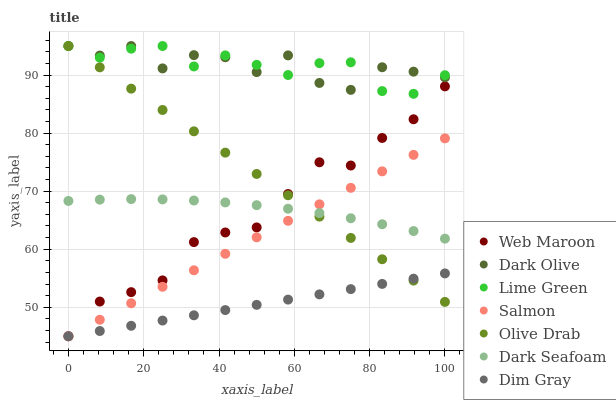Does Dim Gray have the minimum area under the curve?
Answer yes or no. Yes. Does Dark Olive have the maximum area under the curve?
Answer yes or no. Yes. Does Salmon have the minimum area under the curve?
Answer yes or no. No. Does Salmon have the maximum area under the curve?
Answer yes or no. No. Is Dim Gray the smoothest?
Answer yes or no. Yes. Is Dark Olive the roughest?
Answer yes or no. Yes. Is Salmon the smoothest?
Answer yes or no. No. Is Salmon the roughest?
Answer yes or no. No. Does Dim Gray have the lowest value?
Answer yes or no. Yes. Does Dark Olive have the lowest value?
Answer yes or no. No. Does Olive Drab have the highest value?
Answer yes or no. Yes. Does Salmon have the highest value?
Answer yes or no. No. Is Salmon less than Lime Green?
Answer yes or no. Yes. Is Dark Olive greater than Dark Seafoam?
Answer yes or no. Yes. Does Web Maroon intersect Salmon?
Answer yes or no. Yes. Is Web Maroon less than Salmon?
Answer yes or no. No. Is Web Maroon greater than Salmon?
Answer yes or no. No. Does Salmon intersect Lime Green?
Answer yes or no. No. 